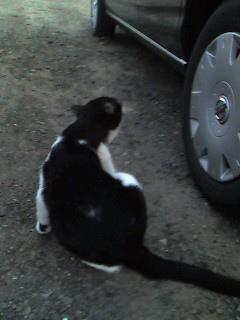What is the cat doing?
Be succinct. Scratching. Is this someone's loved one?
Quick response, please. Yes. What is the percentage of black fur to white fur on the cat?
Short answer required. 80. Is the cat inside the vehicle?
Be succinct. No. 